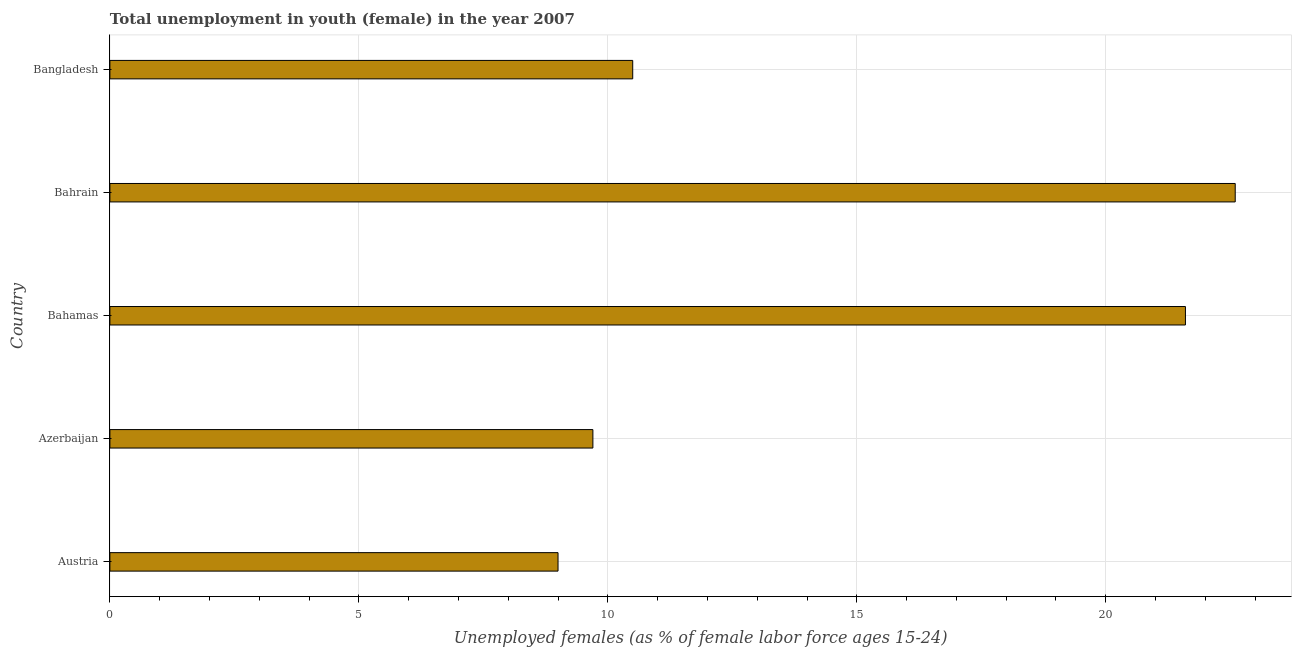What is the title of the graph?
Your answer should be very brief. Total unemployment in youth (female) in the year 2007. What is the label or title of the X-axis?
Keep it short and to the point. Unemployed females (as % of female labor force ages 15-24). What is the label or title of the Y-axis?
Your response must be concise. Country. Across all countries, what is the maximum unemployed female youth population?
Provide a short and direct response. 22.6. In which country was the unemployed female youth population maximum?
Provide a short and direct response. Bahrain. What is the sum of the unemployed female youth population?
Provide a short and direct response. 73.4. What is the difference between the unemployed female youth population in Austria and Bangladesh?
Your answer should be compact. -1.5. What is the average unemployed female youth population per country?
Your response must be concise. 14.68. In how many countries, is the unemployed female youth population greater than 6 %?
Give a very brief answer. 5. What is the ratio of the unemployed female youth population in Bahamas to that in Bahrain?
Make the answer very short. 0.96. Is the unemployed female youth population in Azerbaijan less than that in Bahrain?
Your response must be concise. Yes. Is the difference between the unemployed female youth population in Bahamas and Bahrain greater than the difference between any two countries?
Your answer should be compact. No. What is the difference between the highest and the second highest unemployed female youth population?
Your answer should be very brief. 1. In how many countries, is the unemployed female youth population greater than the average unemployed female youth population taken over all countries?
Your answer should be very brief. 2. How many bars are there?
Make the answer very short. 5. How many countries are there in the graph?
Provide a short and direct response. 5. What is the difference between two consecutive major ticks on the X-axis?
Provide a succinct answer. 5. What is the Unemployed females (as % of female labor force ages 15-24) in Austria?
Give a very brief answer. 9. What is the Unemployed females (as % of female labor force ages 15-24) in Azerbaijan?
Ensure brevity in your answer.  9.7. What is the Unemployed females (as % of female labor force ages 15-24) of Bahamas?
Give a very brief answer. 21.6. What is the Unemployed females (as % of female labor force ages 15-24) of Bahrain?
Give a very brief answer. 22.6. What is the Unemployed females (as % of female labor force ages 15-24) of Bangladesh?
Provide a short and direct response. 10.5. What is the difference between the Unemployed females (as % of female labor force ages 15-24) in Austria and Azerbaijan?
Offer a very short reply. -0.7. What is the difference between the Unemployed females (as % of female labor force ages 15-24) in Austria and Bangladesh?
Offer a terse response. -1.5. What is the difference between the Unemployed females (as % of female labor force ages 15-24) in Azerbaijan and Bangladesh?
Give a very brief answer. -0.8. What is the difference between the Unemployed females (as % of female labor force ages 15-24) in Bahamas and Bahrain?
Make the answer very short. -1. What is the ratio of the Unemployed females (as % of female labor force ages 15-24) in Austria to that in Azerbaijan?
Your answer should be compact. 0.93. What is the ratio of the Unemployed females (as % of female labor force ages 15-24) in Austria to that in Bahamas?
Provide a short and direct response. 0.42. What is the ratio of the Unemployed females (as % of female labor force ages 15-24) in Austria to that in Bahrain?
Keep it short and to the point. 0.4. What is the ratio of the Unemployed females (as % of female labor force ages 15-24) in Austria to that in Bangladesh?
Keep it short and to the point. 0.86. What is the ratio of the Unemployed females (as % of female labor force ages 15-24) in Azerbaijan to that in Bahamas?
Your response must be concise. 0.45. What is the ratio of the Unemployed females (as % of female labor force ages 15-24) in Azerbaijan to that in Bahrain?
Your response must be concise. 0.43. What is the ratio of the Unemployed females (as % of female labor force ages 15-24) in Azerbaijan to that in Bangladesh?
Your answer should be compact. 0.92. What is the ratio of the Unemployed females (as % of female labor force ages 15-24) in Bahamas to that in Bahrain?
Give a very brief answer. 0.96. What is the ratio of the Unemployed females (as % of female labor force ages 15-24) in Bahamas to that in Bangladesh?
Ensure brevity in your answer.  2.06. What is the ratio of the Unemployed females (as % of female labor force ages 15-24) in Bahrain to that in Bangladesh?
Your answer should be very brief. 2.15. 